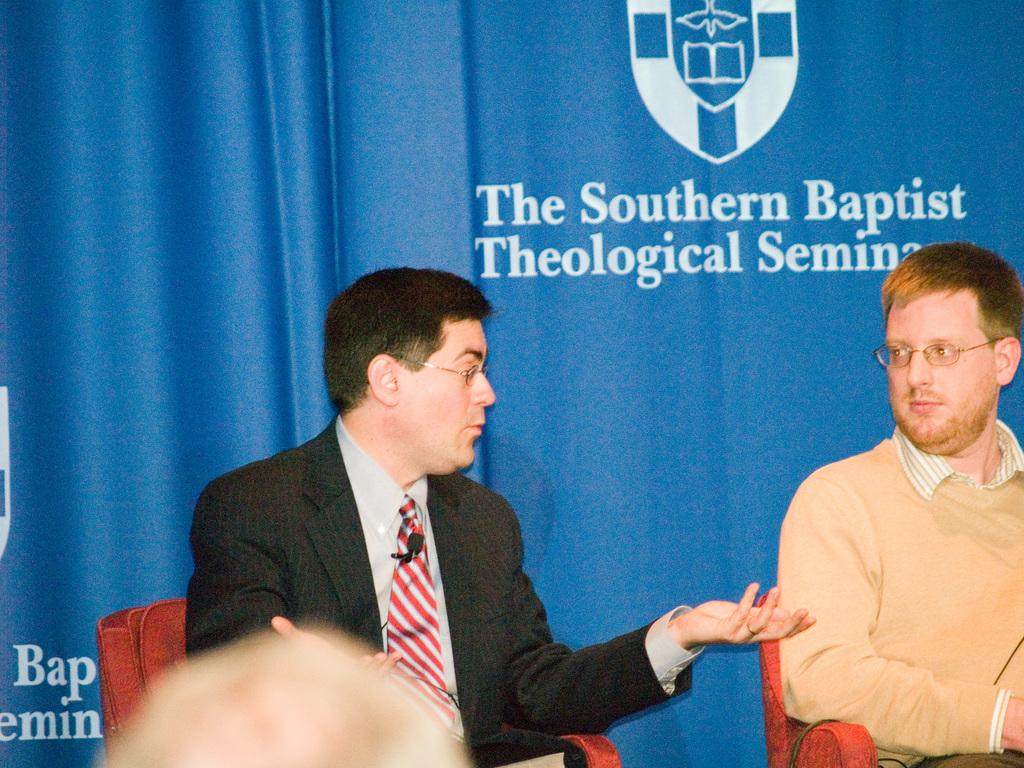How many people are in the image? There are two persons in the image. What are the persons doing in the image? The persons are sitting on chairs. What can be seen on the persons' faces? A: The persons are wearing spectacles. What is visible in the background of the image? There is a cloth in the background of the image. What is written on the cloth? There is writing on the cloth. What type of vessel is being used by the persons for their voyage in the image? There is no vessel or voyage present in the image; it features two persons sitting on chairs and wearing spectacles. 